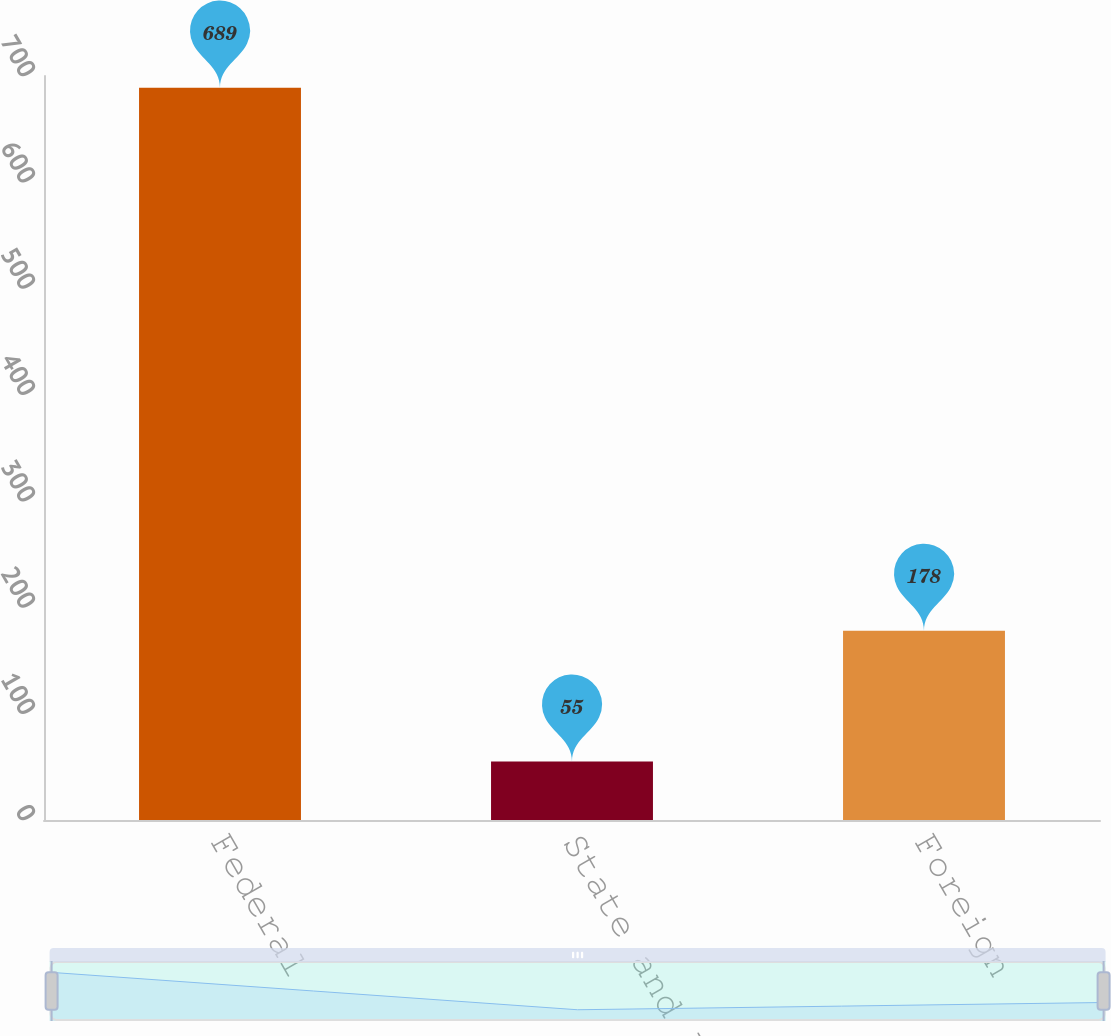<chart> <loc_0><loc_0><loc_500><loc_500><bar_chart><fcel>Federal<fcel>State and local<fcel>Foreign<nl><fcel>689<fcel>55<fcel>178<nl></chart> 